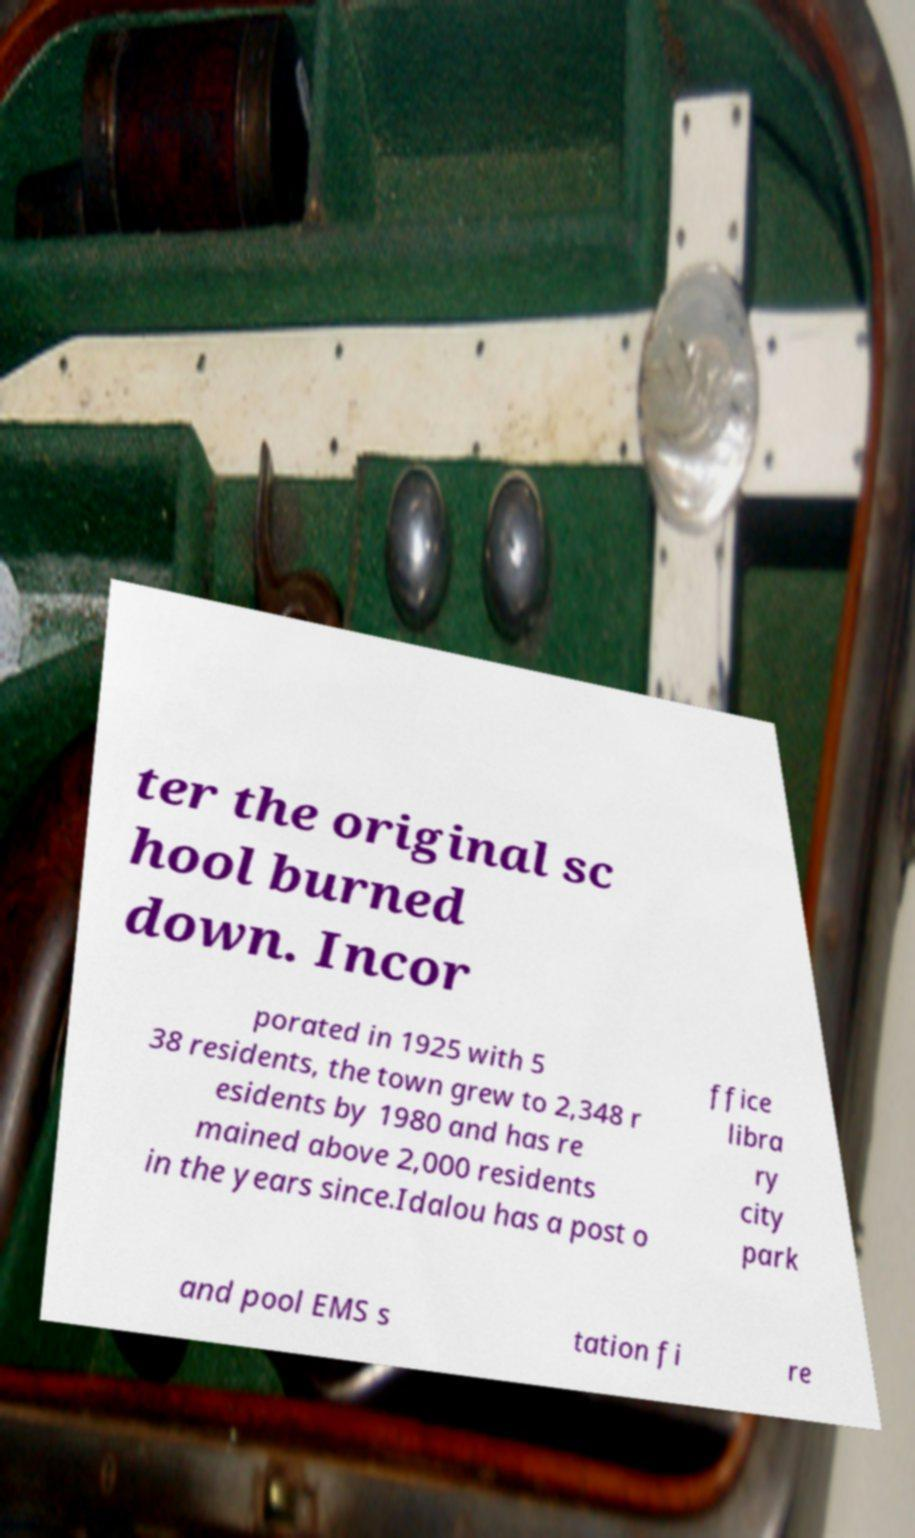Can you accurately transcribe the text from the provided image for me? ter the original sc hool burned down. Incor porated in 1925 with 5 38 residents, the town grew to 2,348 r esidents by 1980 and has re mained above 2,000 residents in the years since.Idalou has a post o ffice libra ry city park and pool EMS s tation fi re 